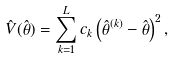Convert formula to latex. <formula><loc_0><loc_0><loc_500><loc_500>\hat { V } ( \hat { \theta } ) = \sum _ { k = 1 } ^ { L } c _ { k } \left ( \hat { \theta } ^ { ( k ) } - \hat { \theta } \right ) ^ { 2 } ,</formula> 